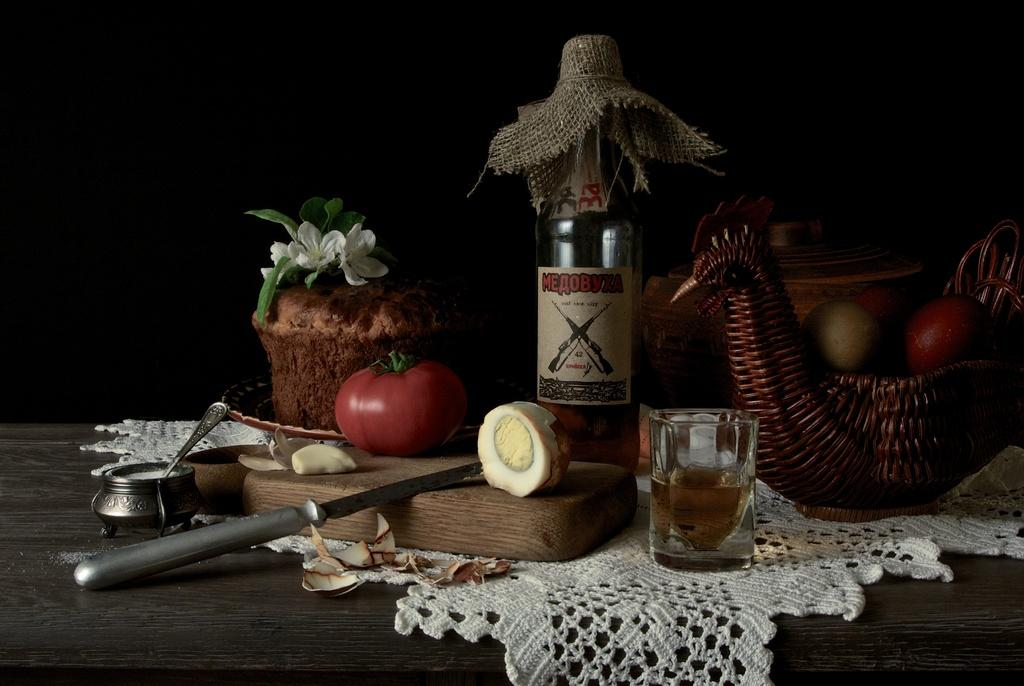What is on the table in the image? There is a glass, an egg, a knife, a spoon, a cloth, a flower, a bottle, and fruits on the table. Can you describe the utensils on the table? There is a knife and a spoon on the table. What type of decoration is on the table? There is a flower on the table. What can be used for cleaning or wiping on the table? There is a cloth on the table for cleaning or wiping. What time is the hourglass showing in the image? There is no hourglass present in the image. What attraction is visible in the image? There is no attraction visible in the image; it features a table with various items on it. 